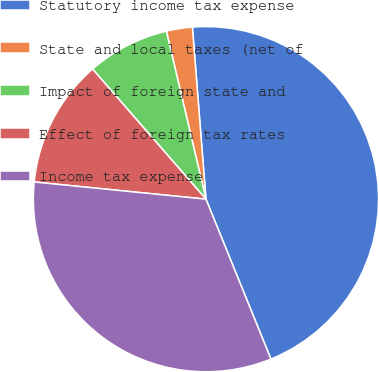<chart> <loc_0><loc_0><loc_500><loc_500><pie_chart><fcel>Statutory income tax expense<fcel>State and local taxes (net of<fcel>Impact of foreign state and<fcel>Effect of foreign tax rates<fcel>Income tax expense<nl><fcel>45.11%<fcel>2.43%<fcel>7.73%<fcel>12.0%<fcel>32.73%<nl></chart> 